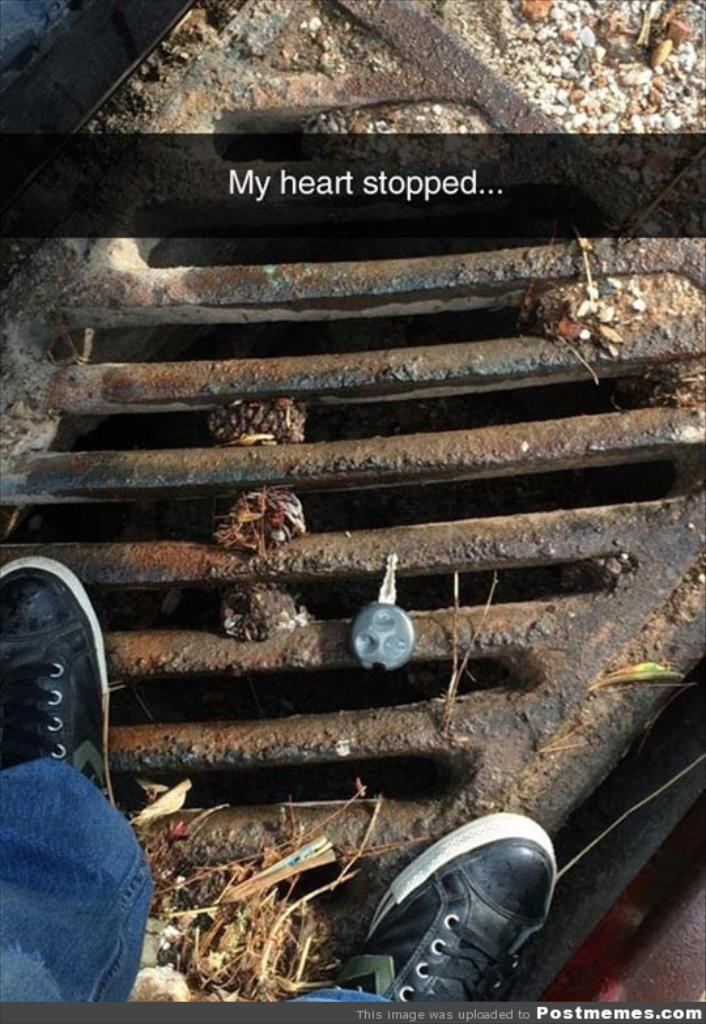What is the person in the image standing on? The person is standing on a manhole cover in the image. What else can be seen on the manhole cover? There is a key on the manhole cover in the image. What phrase is written on the image? The text "My heart stopped" is written on the image. What type of punishment is being administered in the image? There is no punishment being administered in the image; it simply shows a person standing on a manhole cover with a key on it and the text "My heart stopped." 